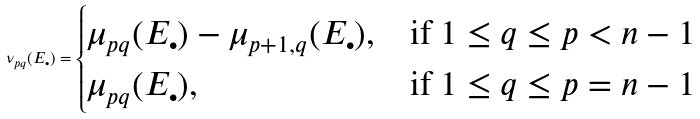<formula> <loc_0><loc_0><loc_500><loc_500>\nu _ { p q } ( E _ { \bullet } ) = \begin{cases} \mu _ { p q } ( E _ { \bullet } ) - \mu _ { p + 1 , q } ( E _ { \bullet } ) , & \text {if } 1 \leq q \leq p < n - 1 \\ \mu _ { p q } ( E _ { \bullet } ) , & \text {if } 1 \leq q \leq p = n - 1 \end{cases}</formula> 